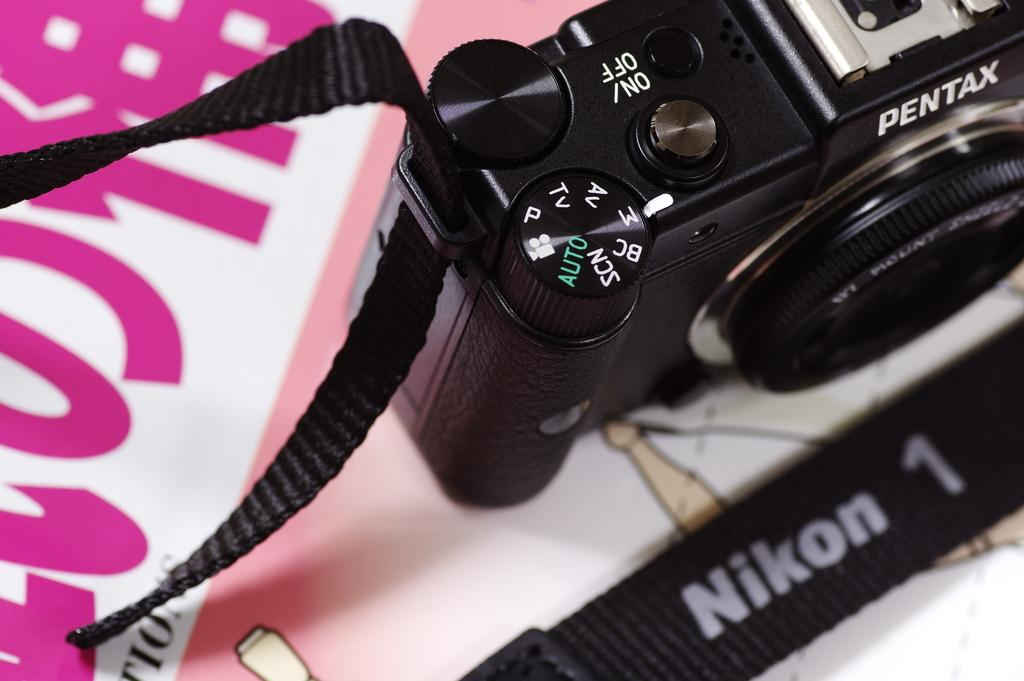What is the main subject of the image? The main subject of the image is a camera. Can you describe the position of the camera in the image? The camera is on an object. Can you see any ghosts in the image? There are no ghosts present in the image. How does the wind affect the camera in the image? The image does not show any wind, and therefore it cannot be determined how the wind might affect the camera. 